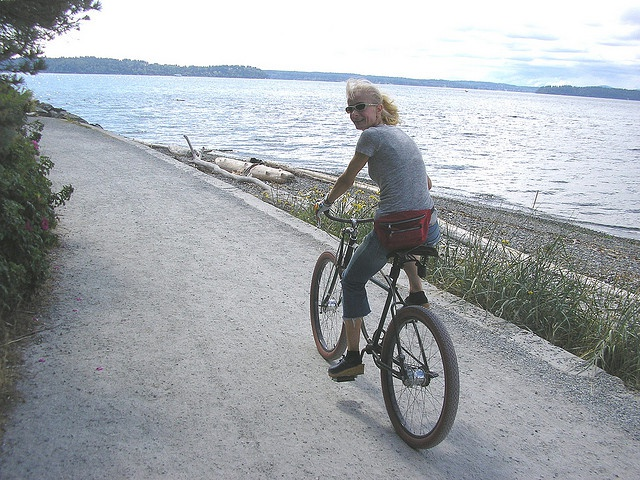Describe the objects in this image and their specific colors. I can see bicycle in darkgreen, gray, darkgray, black, and lightgray tones, people in darkgreen, gray, black, and darkgray tones, and handbag in darkgreen, black, gray, and brown tones in this image. 